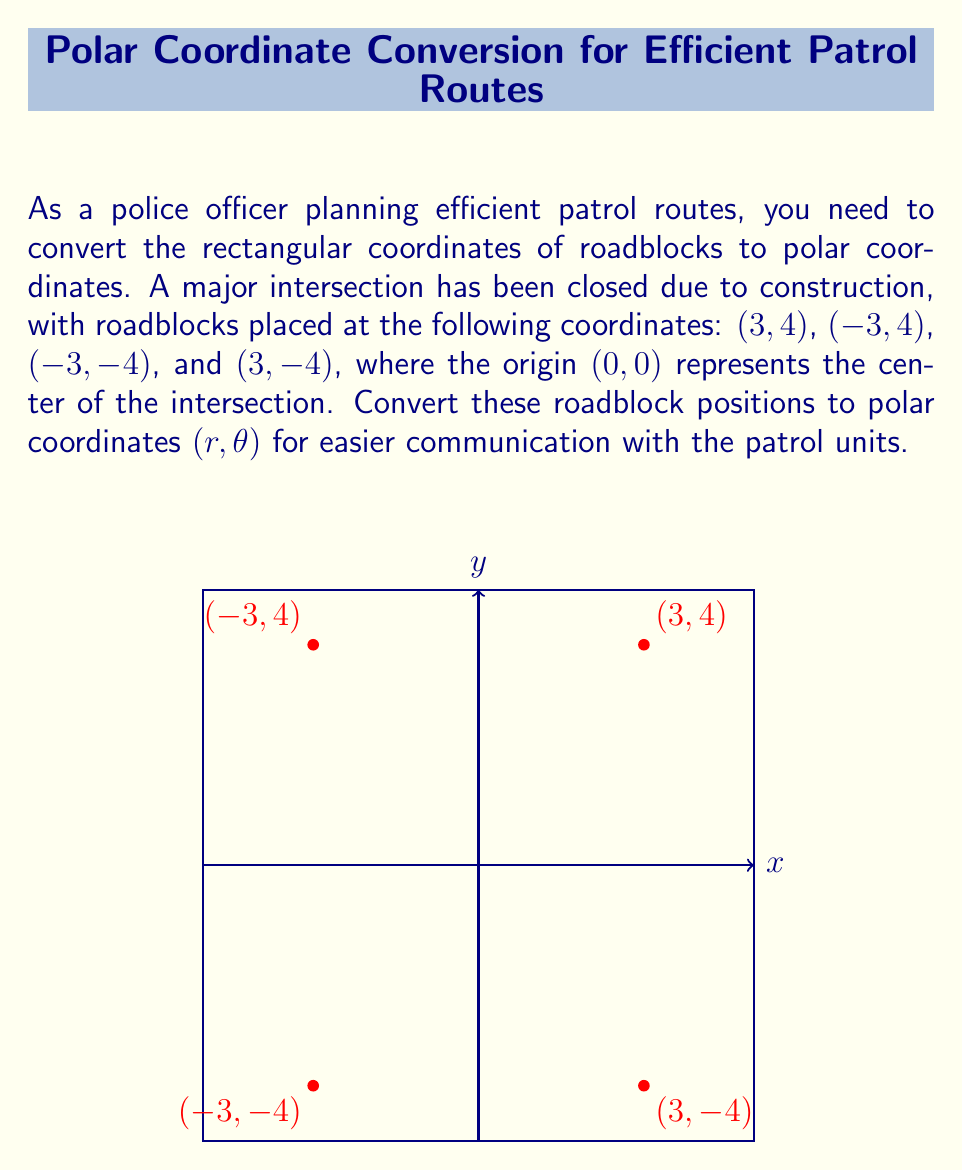Can you answer this question? To convert rectangular coordinates (x, y) to polar coordinates (r, θ), we use the following formulas:

1. $r = \sqrt{x^2 + y^2}$
2. $\theta = \tan^{-1}(\frac{y}{x})$

However, we need to be careful with the arctangent function and adjust the angle based on the quadrant. Let's convert each point:

1. For (3, 4):
   $r = \sqrt{3^2 + 4^2} = \sqrt{9 + 16} = \sqrt{25} = 5$
   $\theta = \tan^{-1}(\frac{4}{3}) \approx 0.9273$ radians or $53.13°$

2. For (-3, 4):
   $r = \sqrt{(-3)^2 + 4^2} = \sqrt{9 + 16} = \sqrt{25} = 5$
   $\theta = \pi + \tan^{-1}(\frac{4}{-3}) \approx 2.2143$ radians or $126.87°$

3. For (-3, -4):
   $r = \sqrt{(-3)^2 + (-4)^2} = \sqrt{9 + 16} = \sqrt{25} = 5$
   $\theta = -\pi + \tan^{-1}(\frac{-4}{-3}) \approx -2.2143$ radians or $-126.87°$

4. For (3, -4):
   $r = \sqrt{3^2 + (-4)^2} = \sqrt{9 + 16} = \sqrt{25} = 5$
   $\theta = -\tan^{-1}(\frac{4}{3}) \approx -0.9273$ radians or $-53.13°$

Note: We can express negative angles as positive ones by adding 2π radians or 360°. So, -126.87° = 233.13° and -53.13° = 306.87°.
Answer: (5, 53.13°), (5, 126.87°), (5, 233.13°), (5, 306.87°) 